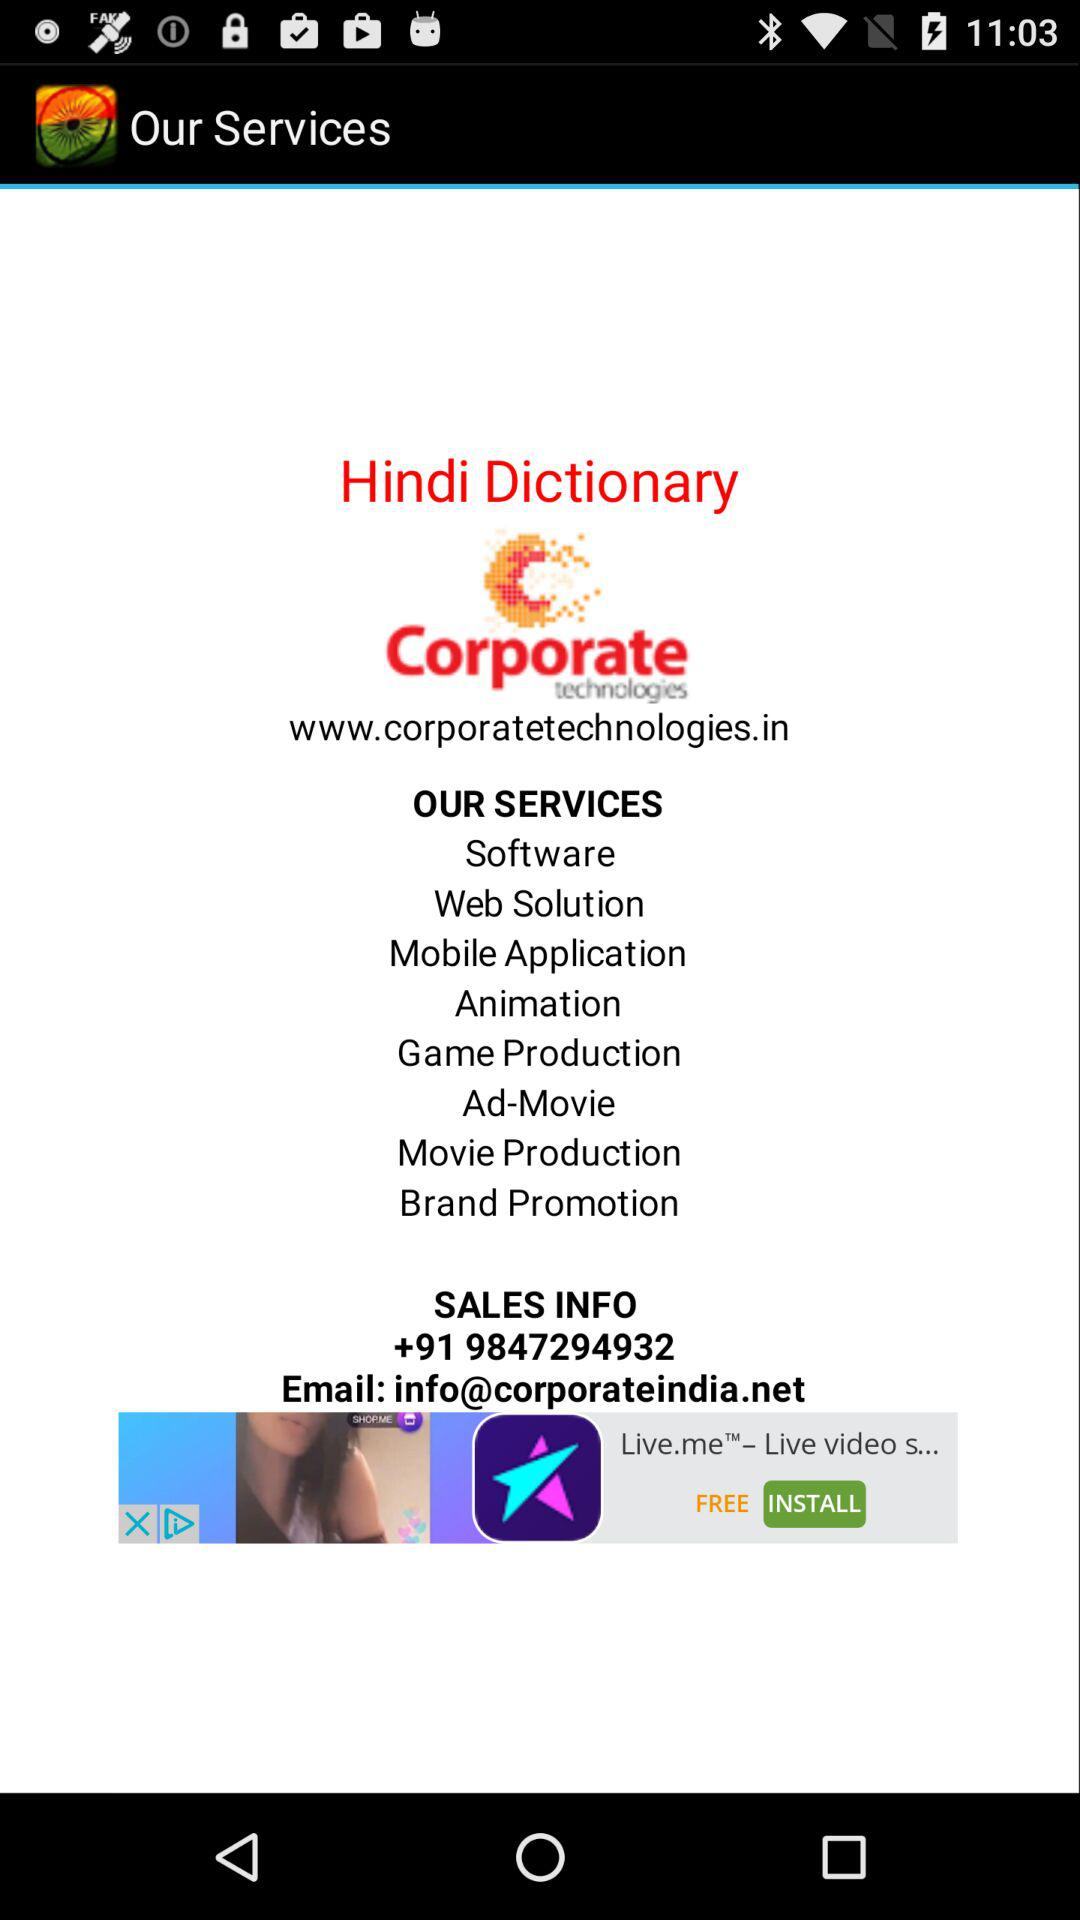What is the contact number for Corporate Technologies? The contact number for Corporate Technologies is +91 9847294932. 